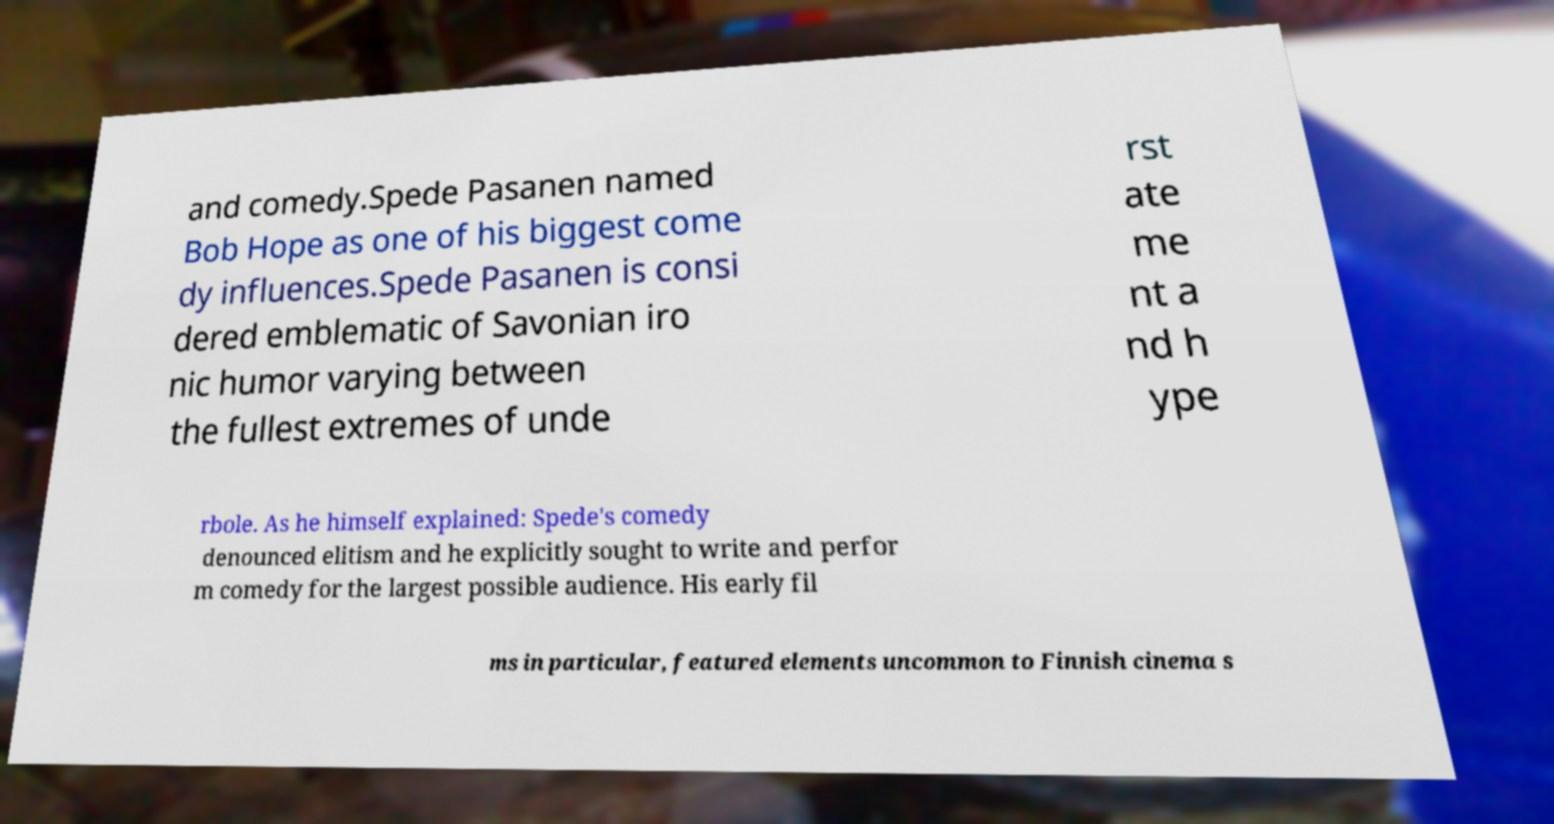Please read and relay the text visible in this image. What does it say? and comedy.Spede Pasanen named Bob Hope as one of his biggest come dy influences.Spede Pasanen is consi dered emblematic of Savonian iro nic humor varying between the fullest extremes of unde rst ate me nt a nd h ype rbole. As he himself explained: Spede's comedy denounced elitism and he explicitly sought to write and perfor m comedy for the largest possible audience. His early fil ms in particular, featured elements uncommon to Finnish cinema s 